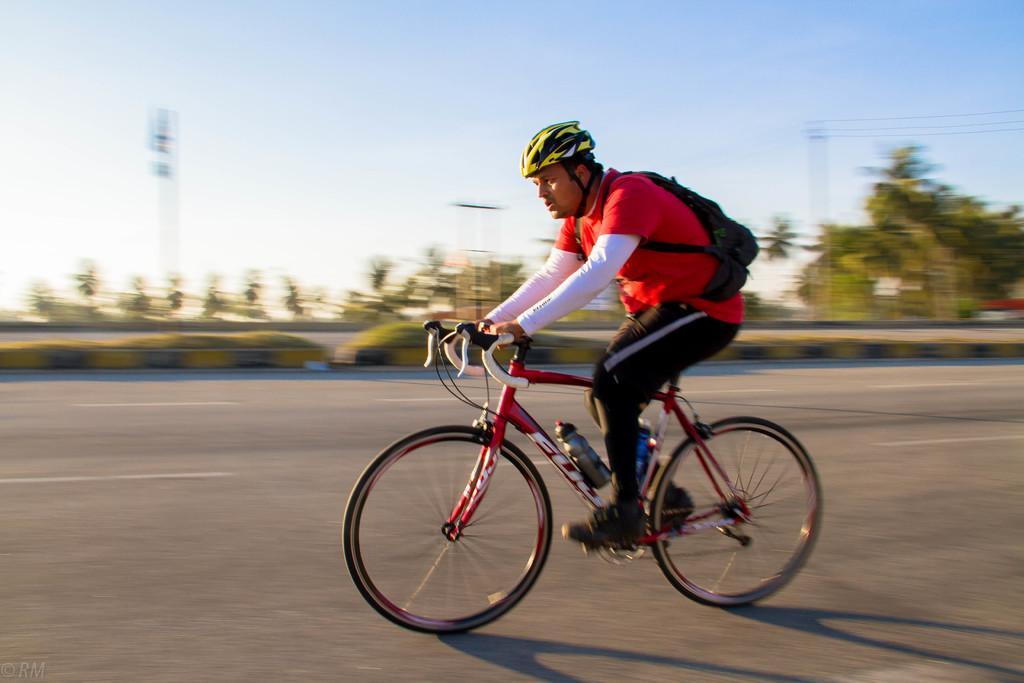Could you give a brief overview of what you see in this image? In this image we can see a person riding a bicycle wearing helmet and bag on the road. In the background of the image there are trees, pole and sky. 